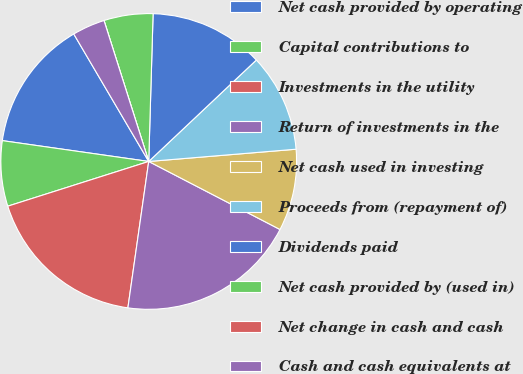Convert chart to OTSL. <chart><loc_0><loc_0><loc_500><loc_500><pie_chart><fcel>Net cash provided by operating<fcel>Capital contributions to<fcel>Investments in the utility<fcel>Return of investments in the<fcel>Net cash used in investing<fcel>Proceeds from (repayment of)<fcel>Dividends paid<fcel>Net cash provided by (used in)<fcel>Net change in cash and cash<fcel>Cash and cash equivalents at<nl><fcel>14.29%<fcel>7.14%<fcel>17.86%<fcel>19.64%<fcel>8.93%<fcel>10.71%<fcel>12.5%<fcel>5.36%<fcel>0.0%<fcel>3.57%<nl></chart> 